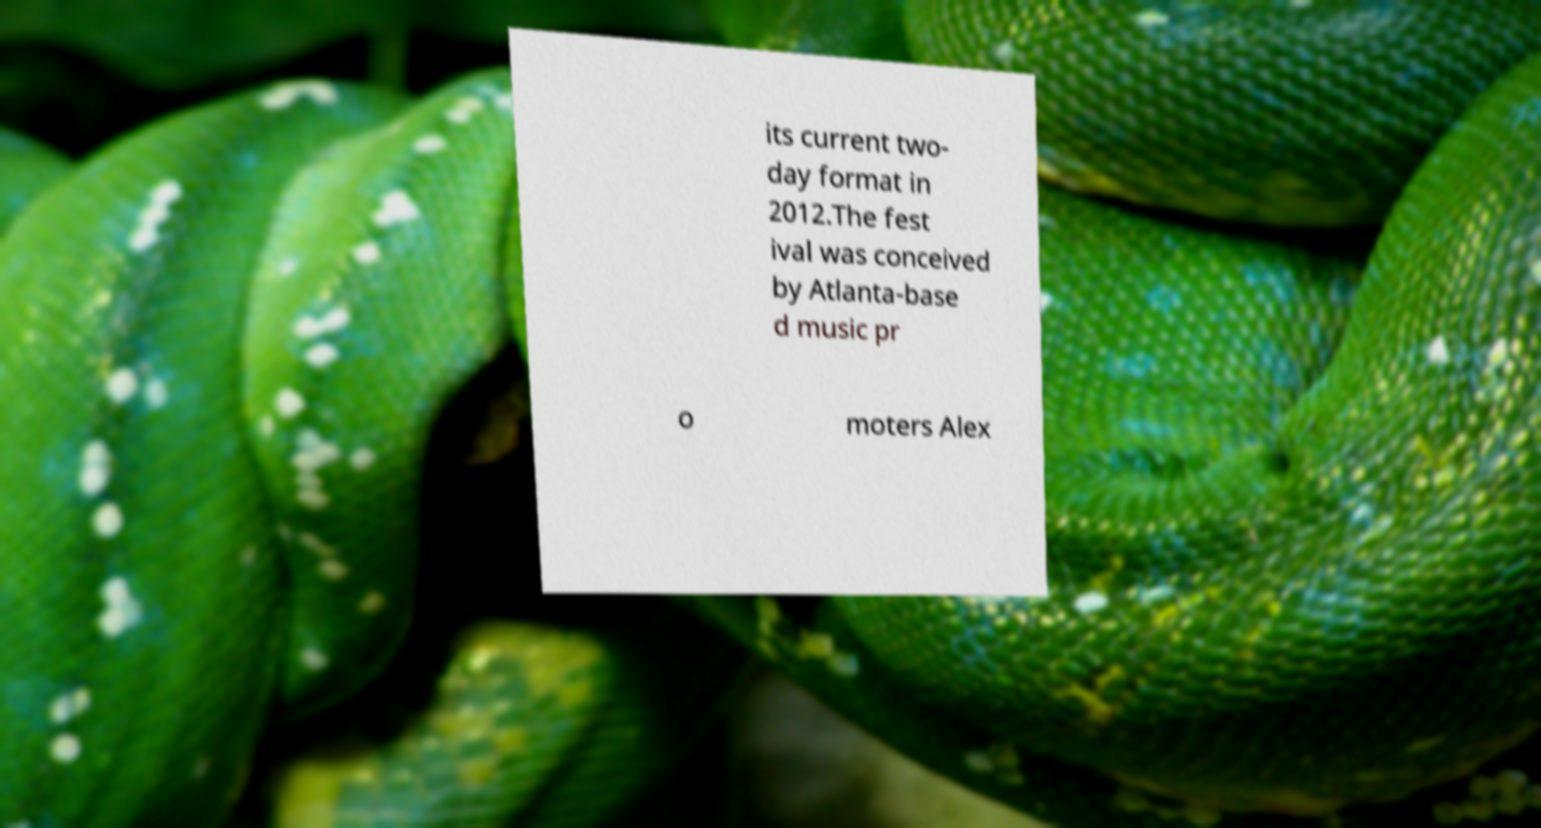There's text embedded in this image that I need extracted. Can you transcribe it verbatim? its current two- day format in 2012.The fest ival was conceived by Atlanta-base d music pr o moters Alex 